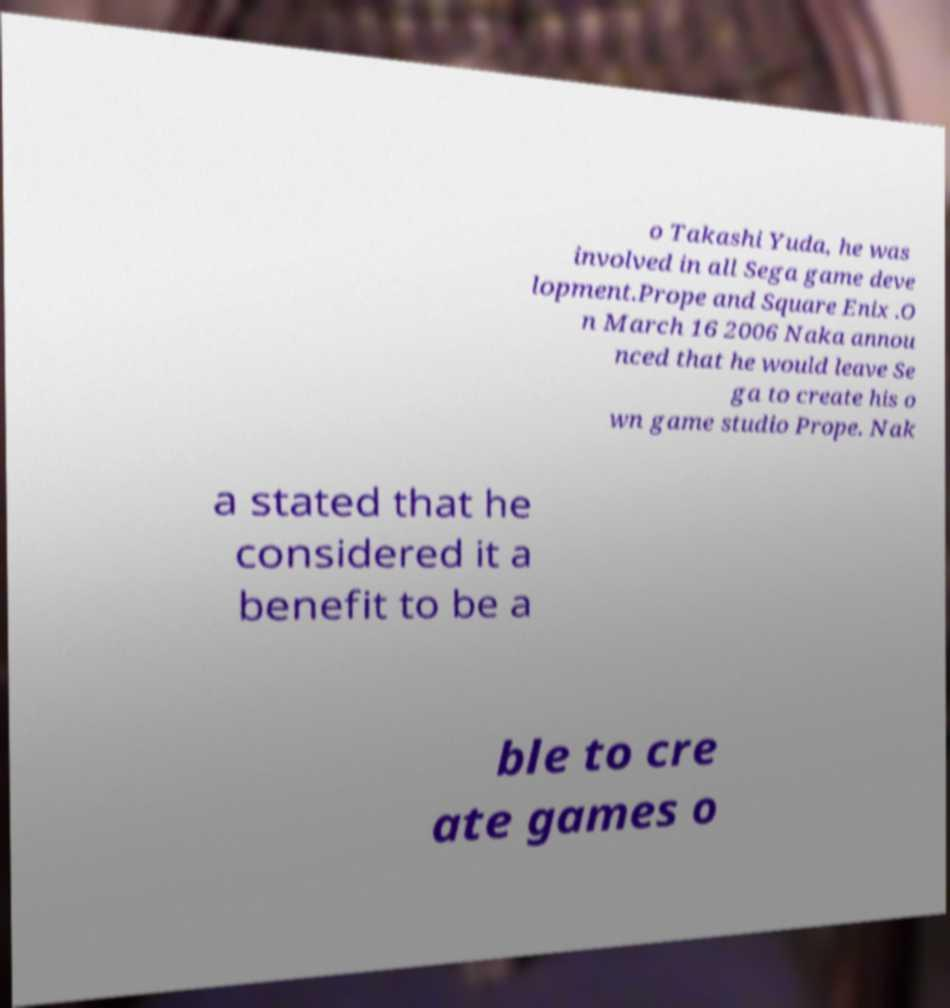There's text embedded in this image that I need extracted. Can you transcribe it verbatim? o Takashi Yuda, he was involved in all Sega game deve lopment.Prope and Square Enix .O n March 16 2006 Naka annou nced that he would leave Se ga to create his o wn game studio Prope. Nak a stated that he considered it a benefit to be a ble to cre ate games o 